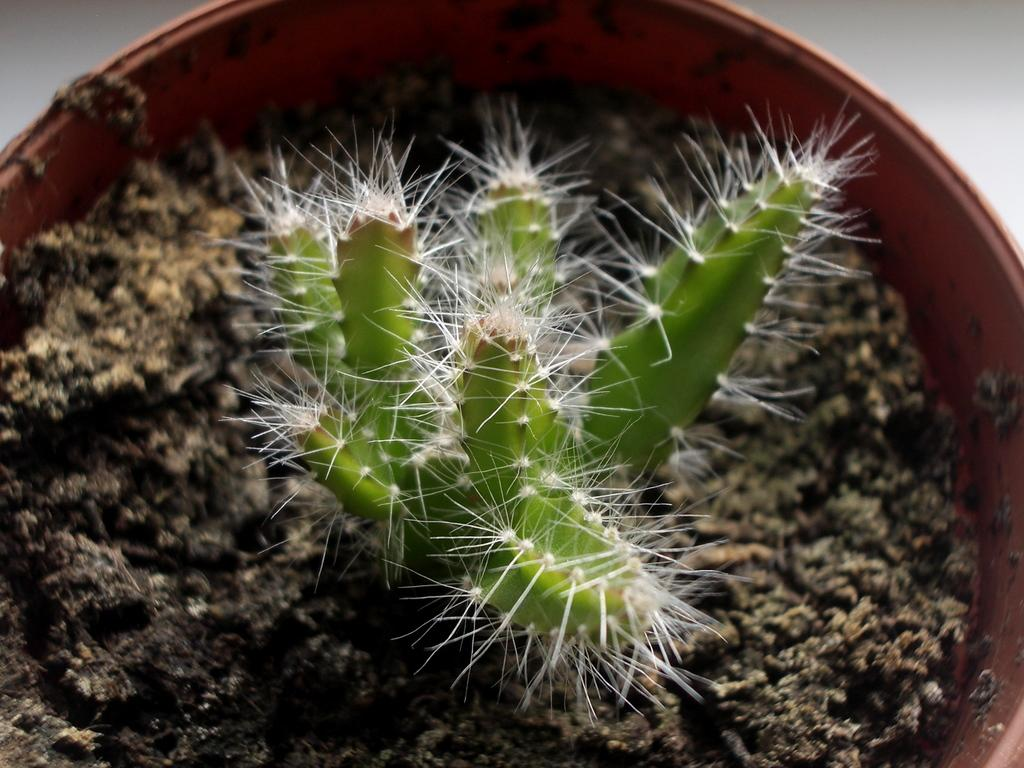What type of plant is in the image? There is a cactus plant in the image. What color is the cactus plant? The cactus plant is green in color. What are the thorns on the cactus plant like? The cactus plant has white thorns. How is the cactus plant contained in the image? The cactus plant is in a small pot. What type of insect is crawling on the calendar in the image? There is no insect or calendar present in the image; it features a cactus plant in a small pot. 